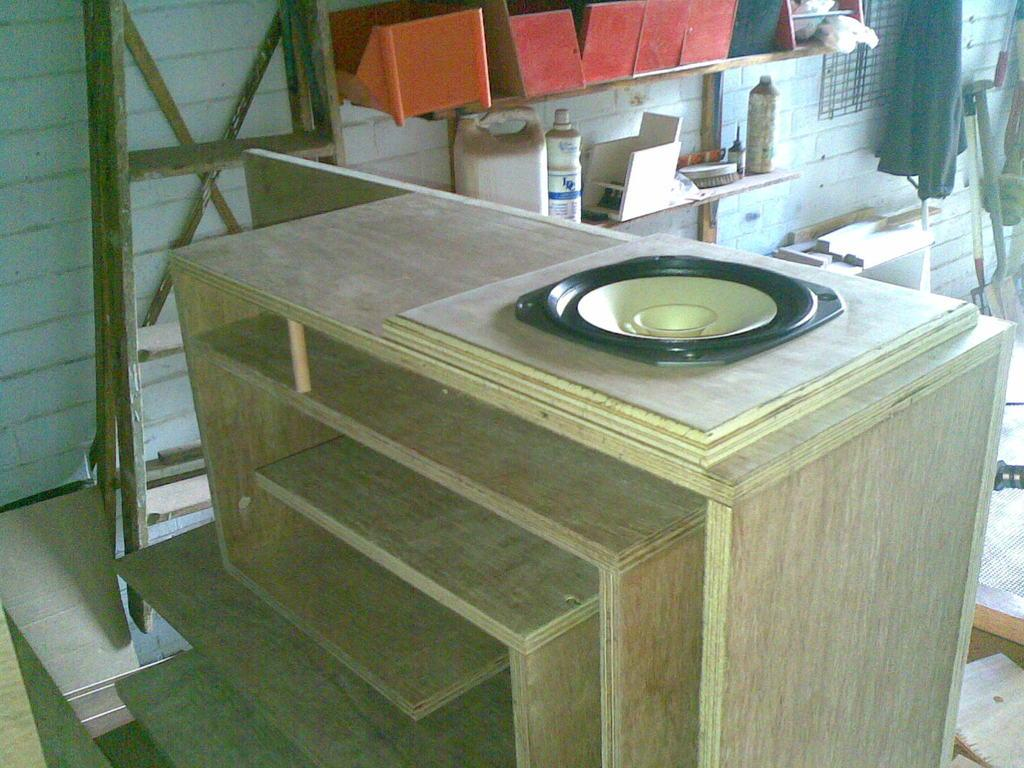What is the main object in the center of the image? There is a wooden rack in the center of the image. What can be seen in the background of the image? There are boxes, bottles, and a ladder in the background of the image. What tool is present in the image? There is a spade in the image. How many chairs are visible in the image? There are no chairs present in the image. What type of wool is being used to create the boxes in the image? There are no boxes made of wool in the image; the boxes are likely made of cardboard or another material. 